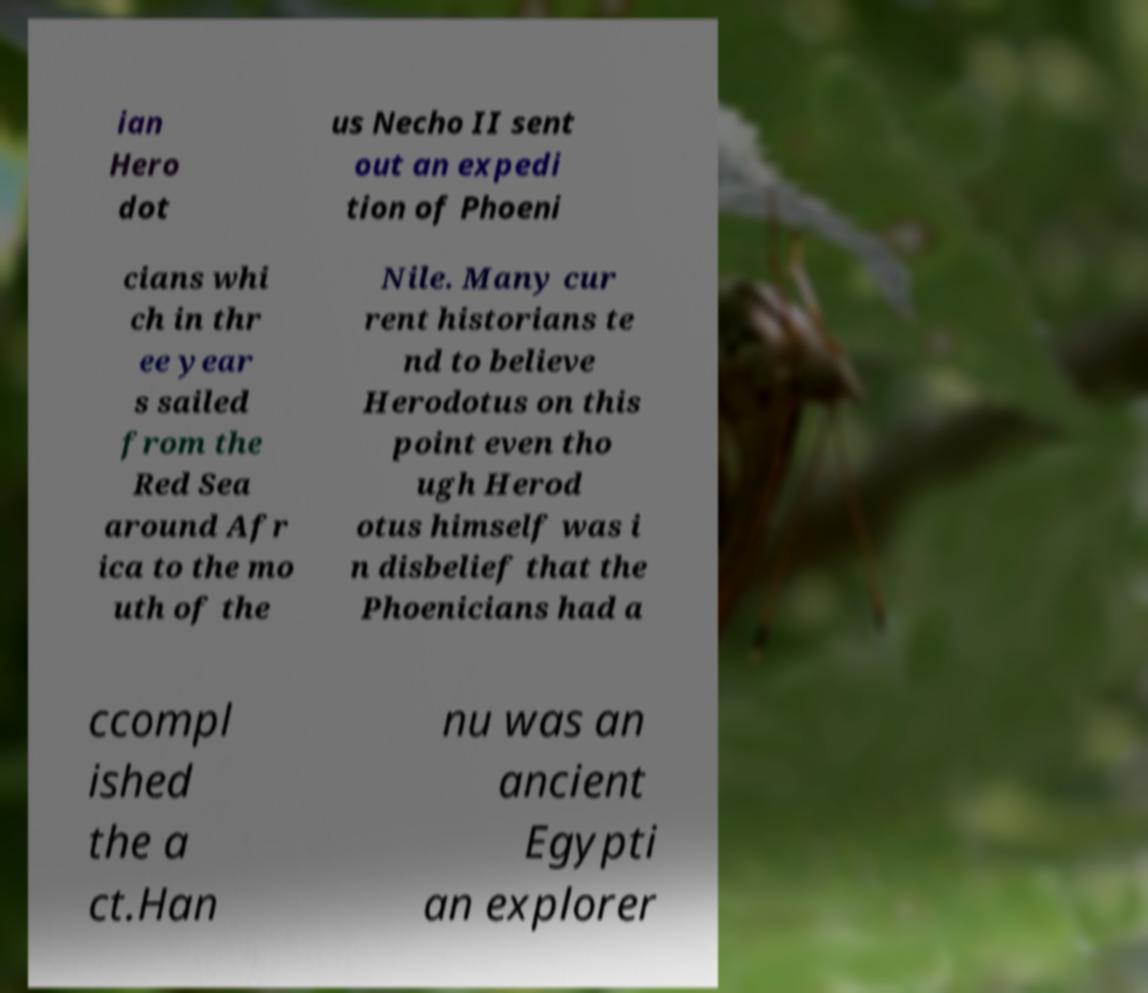Please read and relay the text visible in this image. What does it say? ian Hero dot us Necho II sent out an expedi tion of Phoeni cians whi ch in thr ee year s sailed from the Red Sea around Afr ica to the mo uth of the Nile. Many cur rent historians te nd to believe Herodotus on this point even tho ugh Herod otus himself was i n disbelief that the Phoenicians had a ccompl ished the a ct.Han nu was an ancient Egypti an explorer 